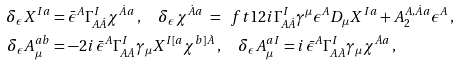<formula> <loc_0><loc_0><loc_500><loc_500>\delta _ { \epsilon } X ^ { I a } & = \bar { \epsilon } ^ { A } \Gamma ^ { I } _ { A \dot { A } } \chi ^ { \dot { A } a } \, , \quad \delta _ { \epsilon } \chi ^ { \dot { A } a } \ = \ \ f t 1 2 i \Gamma ^ { I } _ { A \dot { A } } \gamma ^ { \mu } \epsilon ^ { A } D _ { \mu } X ^ { I a } + A _ { 2 } ^ { A , \dot { A } a } \epsilon ^ { A } \, , \\ \delta _ { \epsilon } A _ { \mu } ^ { a b } & = - 2 i \, \bar { \epsilon } ^ { A } \Gamma ^ { I } _ { A \dot { A } } \gamma _ { \mu } X ^ { I [ a } \chi ^ { b ] \dot { A } } \, , \quad \delta _ { \epsilon } A _ { \mu } ^ { a I } = i \, \bar { \epsilon } ^ { A } \Gamma ^ { I } _ { A \dot { A } } \gamma _ { \mu } \chi ^ { \dot { A } a } \, ,</formula> 